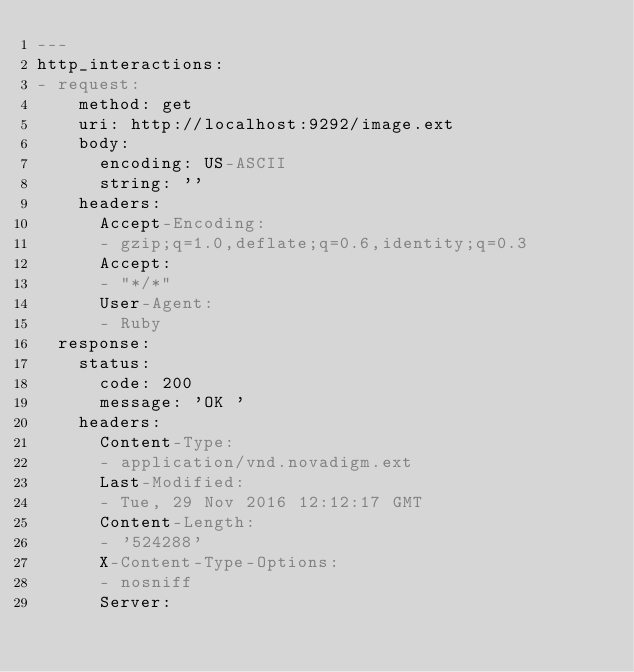<code> <loc_0><loc_0><loc_500><loc_500><_YAML_>---
http_interactions:
- request:
    method: get
    uri: http://localhost:9292/image.ext
    body:
      encoding: US-ASCII
      string: ''
    headers:
      Accept-Encoding:
      - gzip;q=1.0,deflate;q=0.6,identity;q=0.3
      Accept:
      - "*/*"
      User-Agent:
      - Ruby
  response:
    status:
      code: 200
      message: 'OK '
    headers:
      Content-Type:
      - application/vnd.novadigm.ext
      Last-Modified:
      - Tue, 29 Nov 2016 12:12:17 GMT
      Content-Length:
      - '524288'
      X-Content-Type-Options:
      - nosniff
      Server:</code> 